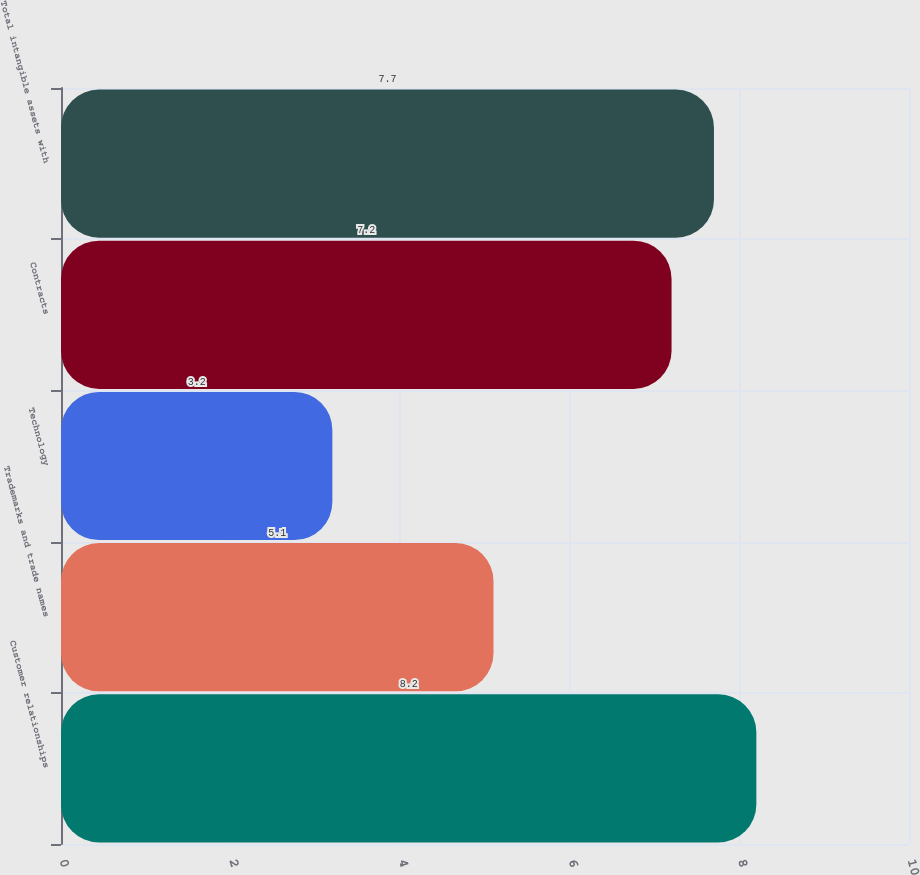Convert chart. <chart><loc_0><loc_0><loc_500><loc_500><bar_chart><fcel>Customer relationships<fcel>Trademarks and trade names<fcel>Technology<fcel>Contracts<fcel>Total intangible assets with<nl><fcel>8.2<fcel>5.1<fcel>3.2<fcel>7.2<fcel>7.7<nl></chart> 